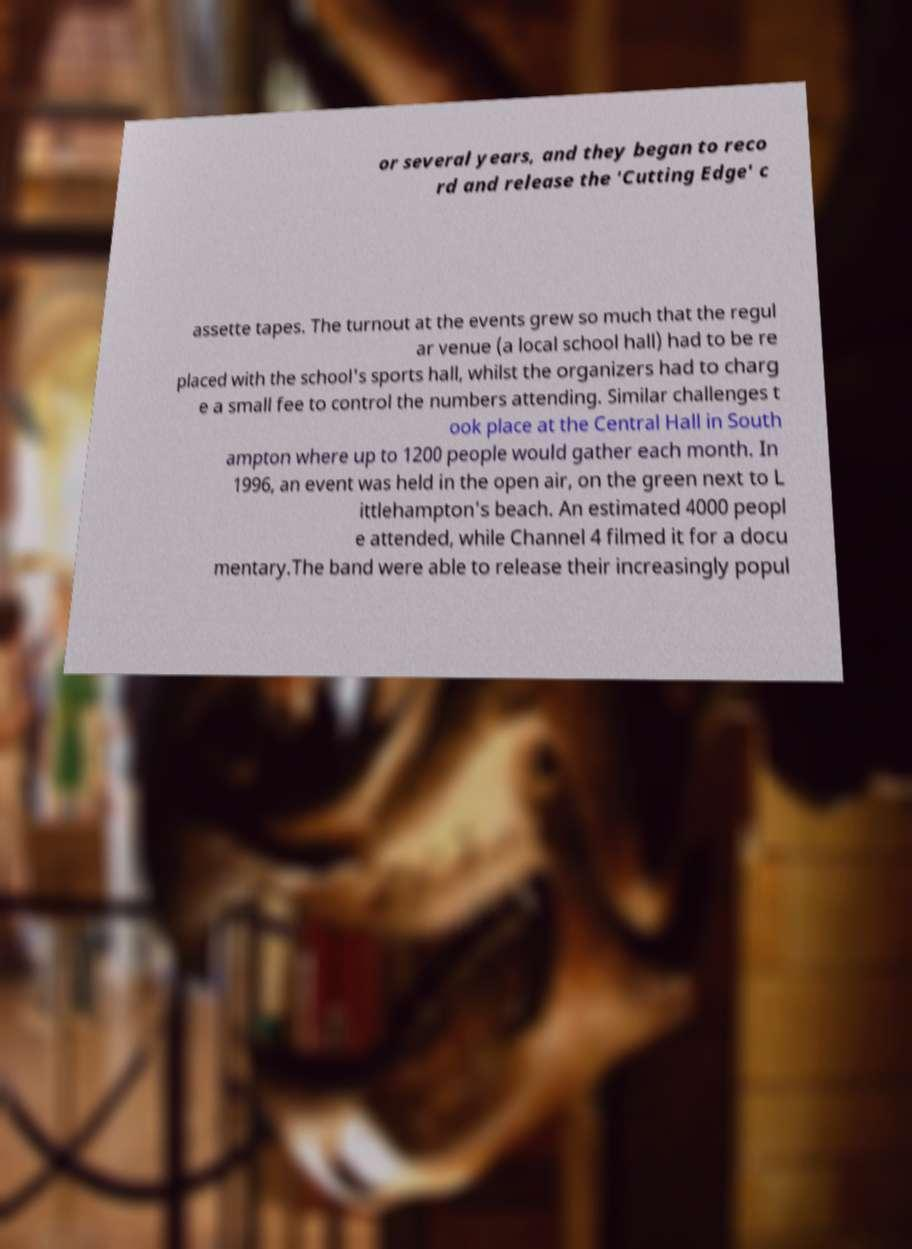What messages or text are displayed in this image? I need them in a readable, typed format. or several years, and they began to reco rd and release the 'Cutting Edge' c assette tapes. The turnout at the events grew so much that the regul ar venue (a local school hall) had to be re placed with the school's sports hall, whilst the organizers had to charg e a small fee to control the numbers attending. Similar challenges t ook place at the Central Hall in South ampton where up to 1200 people would gather each month. In 1996, an event was held in the open air, on the green next to L ittlehampton's beach. An estimated 4000 peopl e attended, while Channel 4 filmed it for a docu mentary.The band were able to release their increasingly popul 